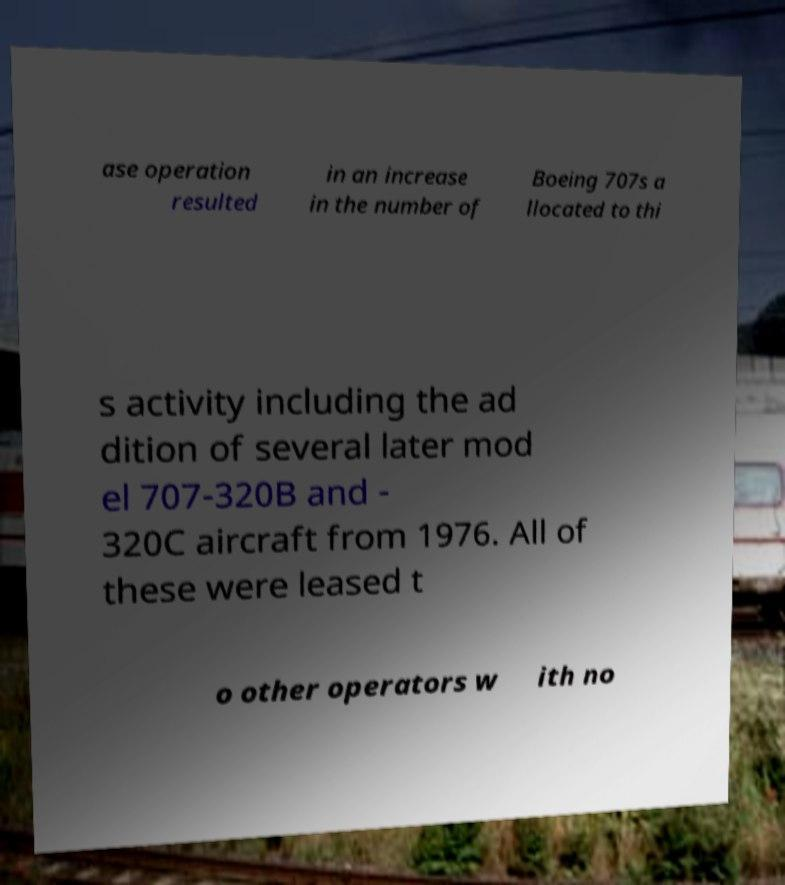Please identify and transcribe the text found in this image. ase operation resulted in an increase in the number of Boeing 707s a llocated to thi s activity including the ad dition of several later mod el 707-320B and - 320C aircraft from 1976. All of these were leased t o other operators w ith no 